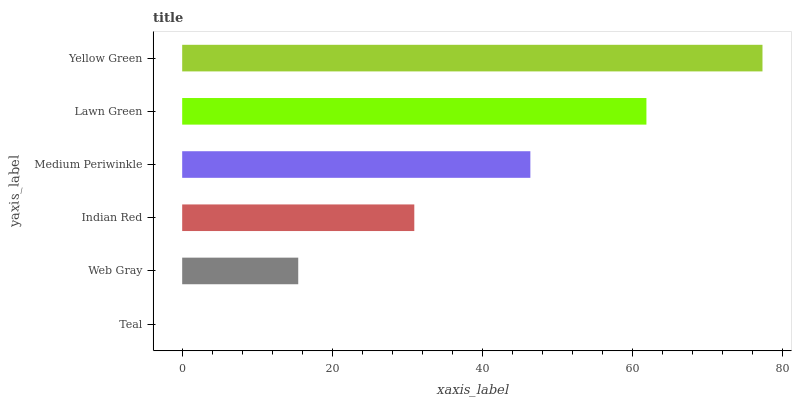Is Teal the minimum?
Answer yes or no. Yes. Is Yellow Green the maximum?
Answer yes or no. Yes. Is Web Gray the minimum?
Answer yes or no. No. Is Web Gray the maximum?
Answer yes or no. No. Is Web Gray greater than Teal?
Answer yes or no. Yes. Is Teal less than Web Gray?
Answer yes or no. Yes. Is Teal greater than Web Gray?
Answer yes or no. No. Is Web Gray less than Teal?
Answer yes or no. No. Is Medium Periwinkle the high median?
Answer yes or no. Yes. Is Indian Red the low median?
Answer yes or no. Yes. Is Indian Red the high median?
Answer yes or no. No. Is Web Gray the low median?
Answer yes or no. No. 